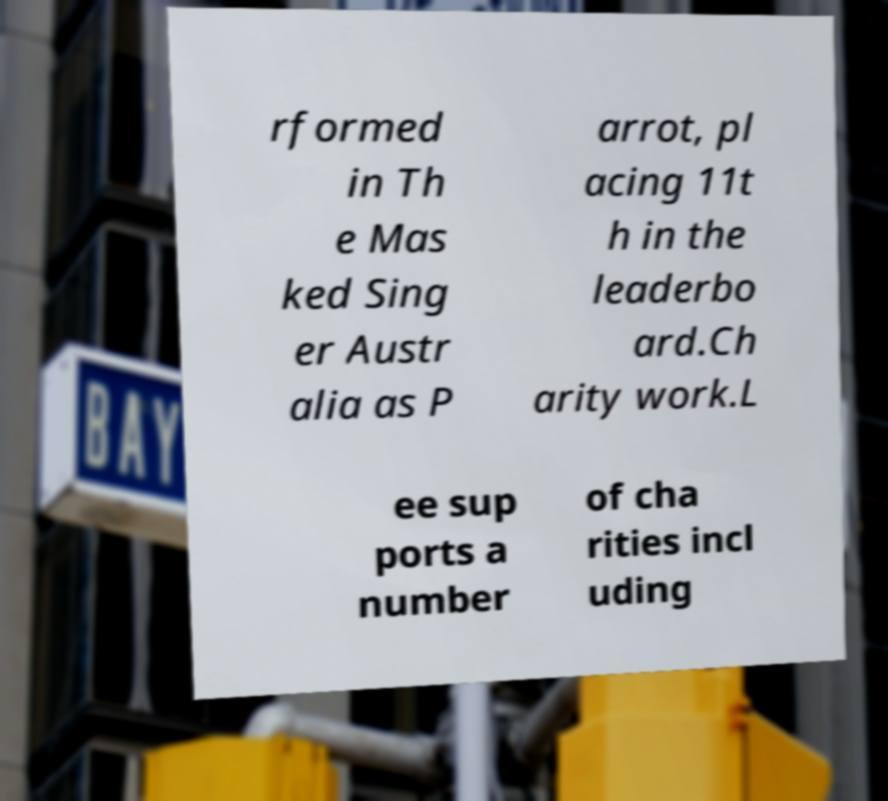Can you read and provide the text displayed in the image?This photo seems to have some interesting text. Can you extract and type it out for me? rformed in Th e Mas ked Sing er Austr alia as P arrot, pl acing 11t h in the leaderbo ard.Ch arity work.L ee sup ports a number of cha rities incl uding 